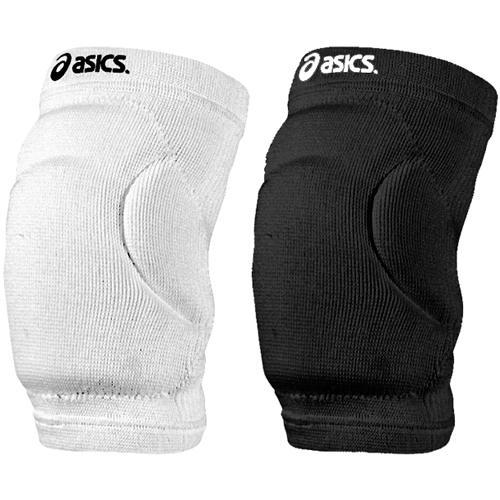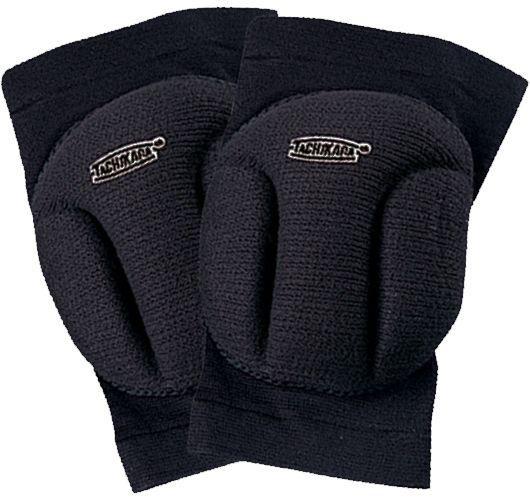The first image is the image on the left, the second image is the image on the right. Examine the images to the left and right. Is the description "A white kneepad is next to a black kneepad in at least one of the images." accurate? Answer yes or no. Yes. The first image is the image on the left, the second image is the image on the right. Evaluate the accuracy of this statement regarding the images: "The right image contains exactly two black knee pads.". Is it true? Answer yes or no. Yes. 